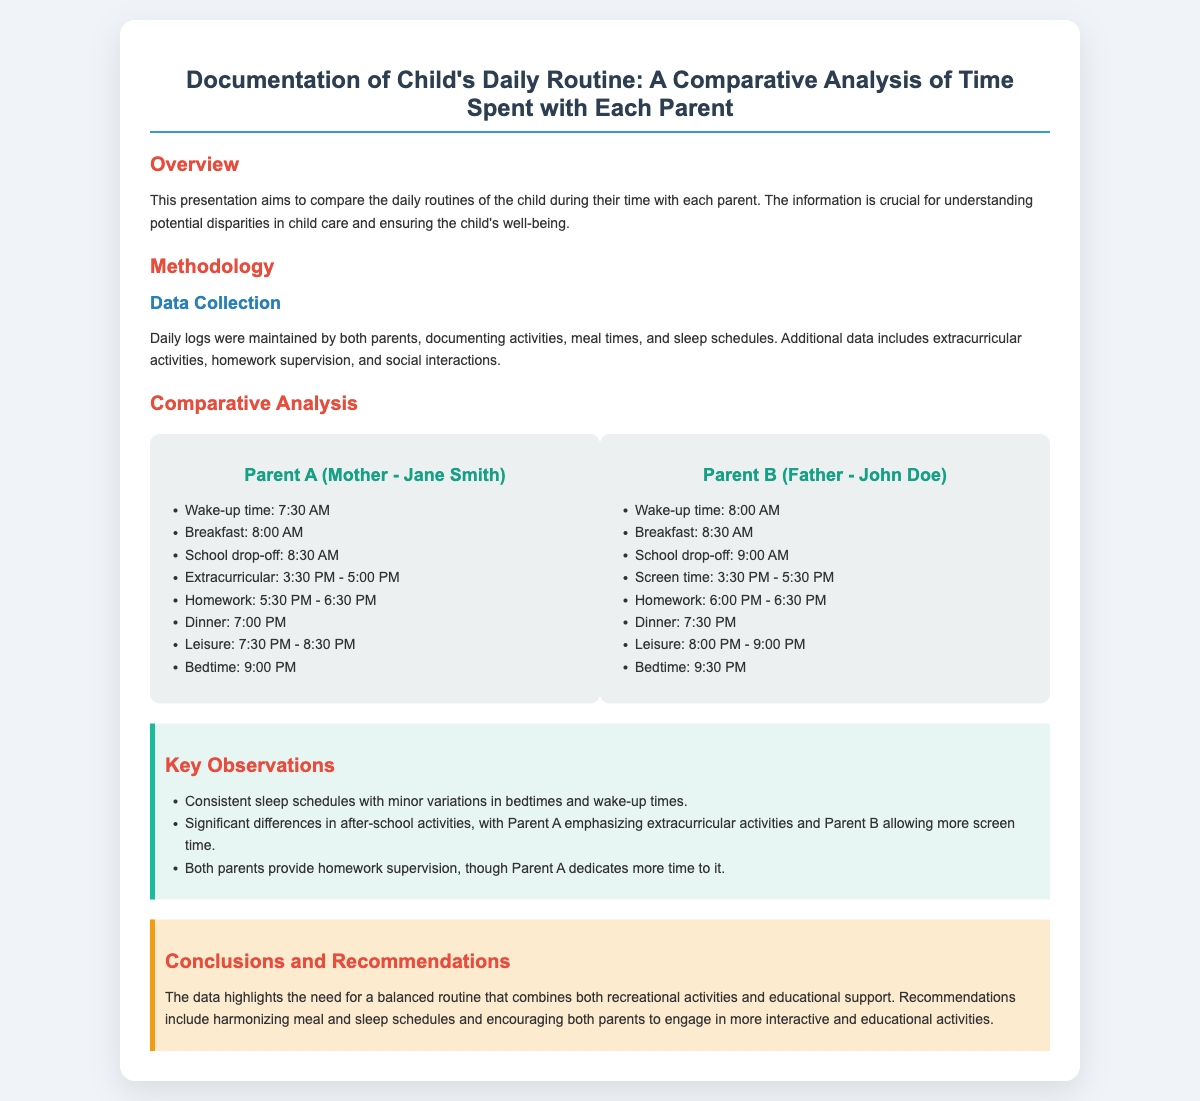What is the wake-up time for Parent A? The wake-up time for Parent A is listed in the daily routine, which is 7:30 AM.
Answer: 7:30 AM What activity occurs from 3:30 PM to 5:00 PM with Parent A? The activity scheduled during this time with Parent A is extracurricular activities, as mentioned in the comparative analysis section.
Answer: Extracurricular How much time does Parent A dedicate to homework? The document specifies that Parent A dedicates one hour to homework from 5:30 PM to 6:30 PM.
Answer: 1 hour What is the bedtime for Parent B? The bedtime for Parent B is indicated in the child’s daily routine logs, which is 9:30 PM.
Answer: 9:30 PM Which parent allows more screen time? The analysis identifies Parent B as allowing more screen time during after-school hours, specifically mentioned in the observations.
Answer: Parent B What is the main focus of Parent A's daily activities? The emphasis of Parent A's daily activities appears to be on extracurricular activities after school, based on comparisons made in the document.
Answer: Extracurricular activities What is the purpose of this presentation? The purpose of the presentation, detailed in the overview section, is to compare the daily routines of the child with each parent.
Answer: Compare daily routines What is one key observation made about sleep schedules? The document notes that both parents maintain consistent sleep schedules, with only minor variations in bedtimes and wake-up times.
Answer: Consistent sleep schedules What recommendation is suggested in the conclusions? The presentation recommends harmonizing meal and sleep schedules for the well-being of the child, as outlined in the conclusions section.
Answer: Harmonizing meal and sleep schedules 